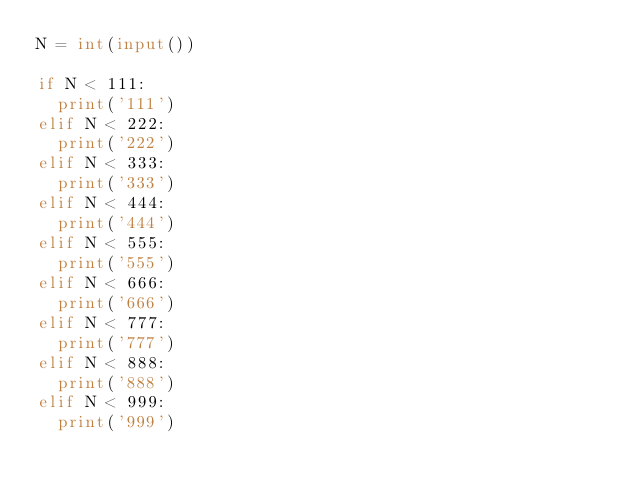<code> <loc_0><loc_0><loc_500><loc_500><_Python_>N = int(input())

if N < 111:
  print('111')
elif N < 222:
  print('222')
elif N < 333:
  print('333')
elif N < 444:
  print('444')
elif N < 555:
  print('555')
elif N < 666:
  print('666')
elif N < 777:
  print('777')
elif N < 888:
  print('888')
elif N < 999:
  print('999')</code> 